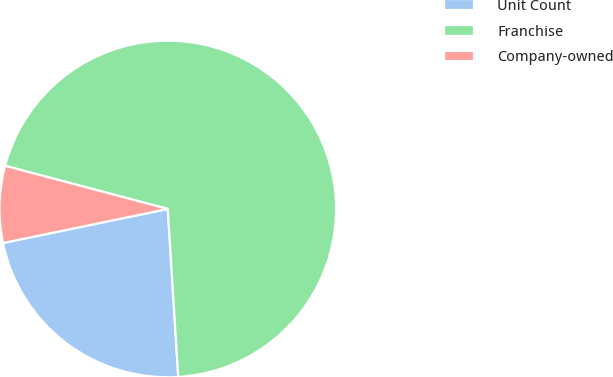<chart> <loc_0><loc_0><loc_500><loc_500><pie_chart><fcel>Unit Count<fcel>Franchise<fcel>Company-owned<nl><fcel>22.75%<fcel>69.88%<fcel>7.37%<nl></chart> 